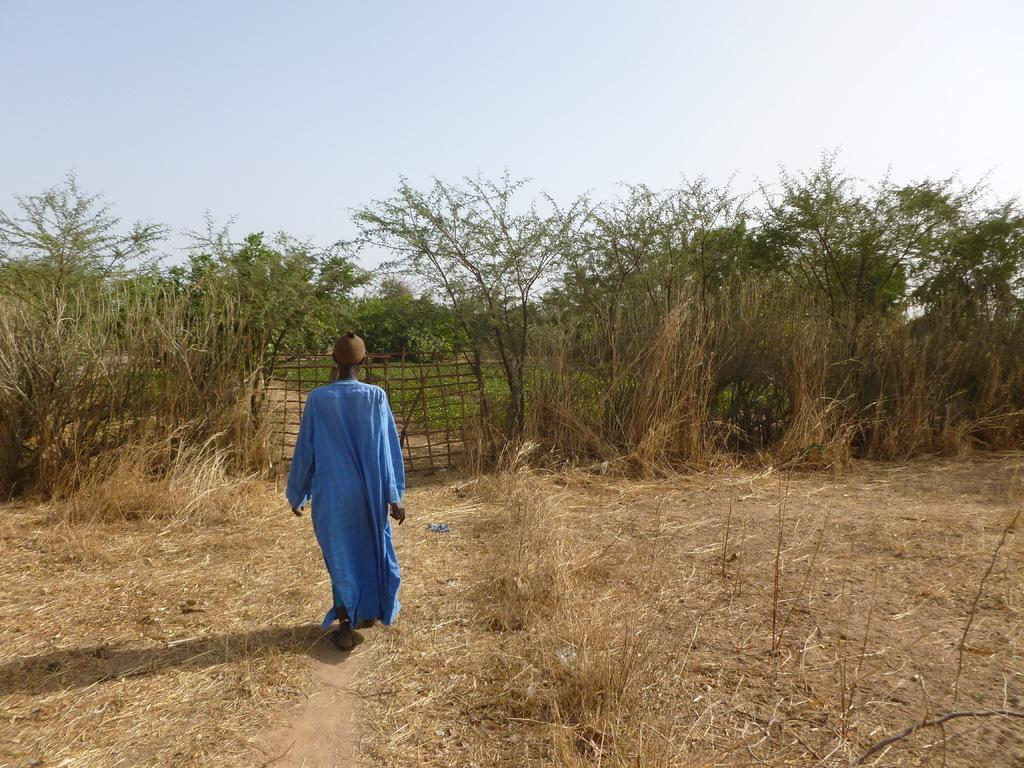Who is present in the image? There is a man in the picture. What is the man doing in the image? The man is walking. What type of vegetation can be seen in the image? There are plants and trees in the image. What is the man wearing in the image? The man is wearing a blue shirt. What decision does the man make while walking in the image? There is no indication in the image that the man is making any decisions while walking. 